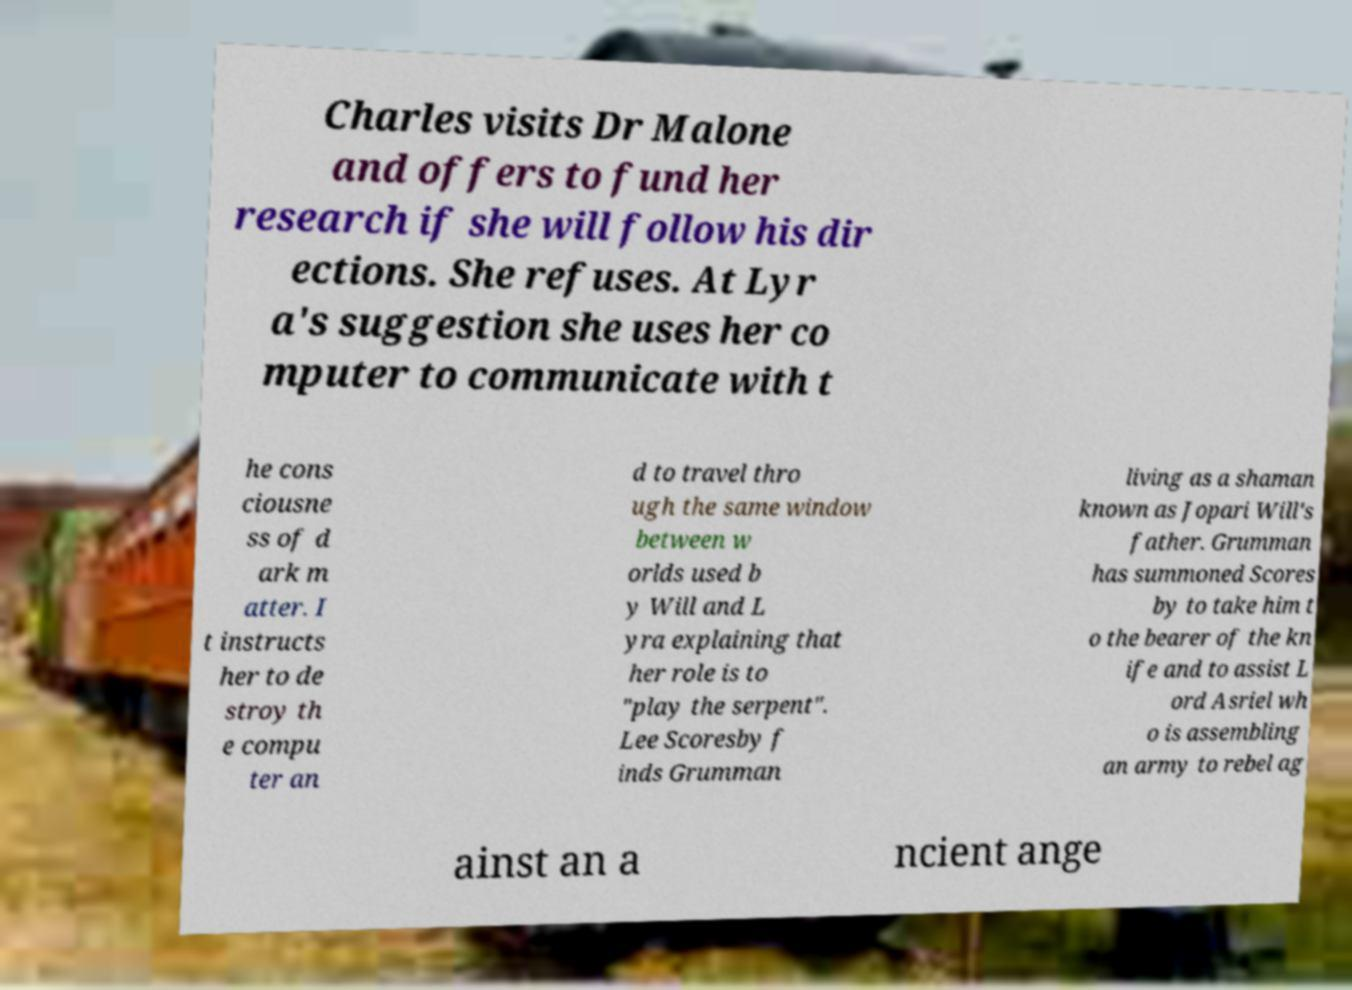What messages or text are displayed in this image? I need them in a readable, typed format. Charles visits Dr Malone and offers to fund her research if she will follow his dir ections. She refuses. At Lyr a's suggestion she uses her co mputer to communicate with t he cons ciousne ss of d ark m atter. I t instructs her to de stroy th e compu ter an d to travel thro ugh the same window between w orlds used b y Will and L yra explaining that her role is to "play the serpent". Lee Scoresby f inds Grumman living as a shaman known as Jopari Will's father. Grumman has summoned Scores by to take him t o the bearer of the kn ife and to assist L ord Asriel wh o is assembling an army to rebel ag ainst an a ncient ange 